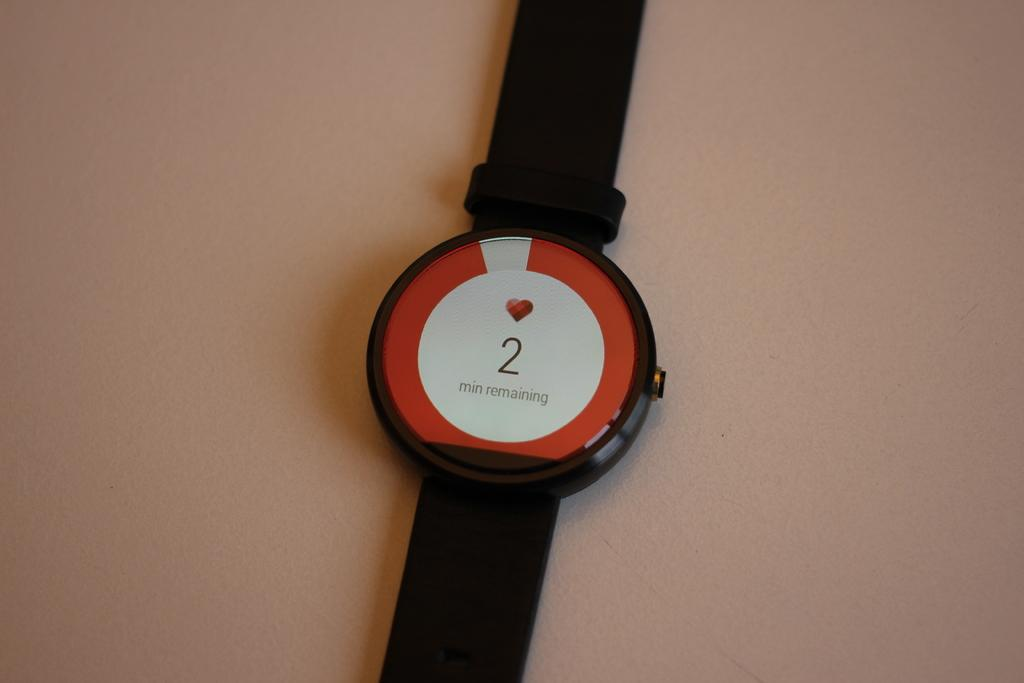Provide a one-sentence caption for the provided image. A watch that has a heart stone and 2 minutes remaining. 